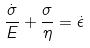Convert formula to latex. <formula><loc_0><loc_0><loc_500><loc_500>\frac { \dot { \sigma } } { E } + \frac { \sigma } { \eta } = \dot { \epsilon }</formula> 